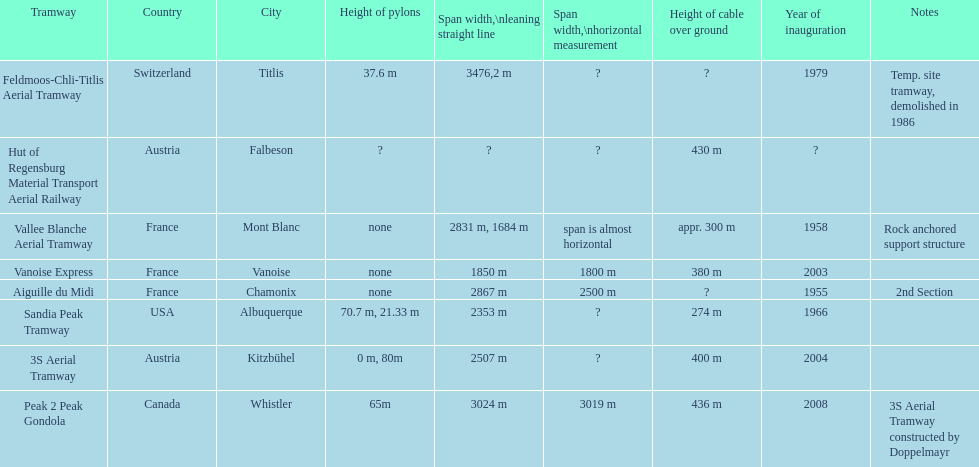How many aerial tramways are located in france? 3. 